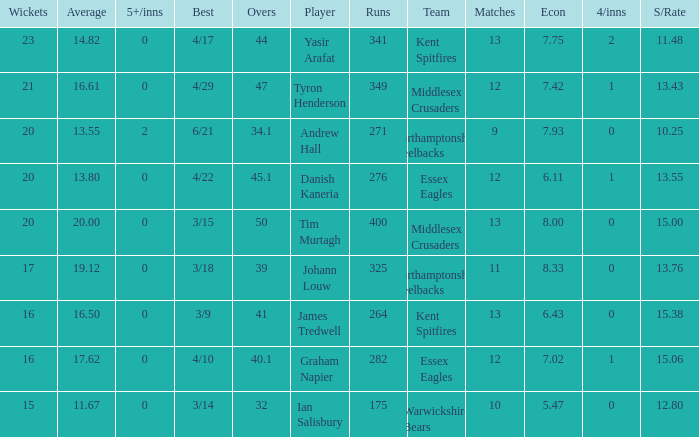Could you help me parse every detail presented in this table? {'header': ['Wickets', 'Average', '5+/inns', 'Best', 'Overs', 'Player', 'Runs', 'Team', 'Matches', 'Econ', '4/inns', 'S/Rate'], 'rows': [['23', '14.82', '0', '4/17', '44', 'Yasir Arafat', '341', 'Kent Spitfires', '13', '7.75', '2', '11.48'], ['21', '16.61', '0', '4/29', '47', 'Tyron Henderson', '349', 'Middlesex Crusaders', '12', '7.42', '1', '13.43'], ['20', '13.55', '2', '6/21', '34.1', 'Andrew Hall', '271', 'Northamptonshire Steelbacks', '9', '7.93', '0', '10.25'], ['20', '13.80', '0', '4/22', '45.1', 'Danish Kaneria', '276', 'Essex Eagles', '12', '6.11', '1', '13.55'], ['20', '20.00', '0', '3/15', '50', 'Tim Murtagh', '400', 'Middlesex Crusaders', '13', '8.00', '0', '15.00'], ['17', '19.12', '0', '3/18', '39', 'Johann Louw', '325', 'Northamptonshire Steelbacks', '11', '8.33', '0', '13.76'], ['16', '16.50', '0', '3/9', '41', 'James Tredwell', '264', 'Kent Spitfires', '13', '6.43', '0', '15.38'], ['16', '17.62', '0', '4/10', '40.1', 'Graham Napier', '282', 'Essex Eagles', '12', '7.02', '1', '15.06'], ['15', '11.67', '0', '3/14', '32', 'Ian Salisbury', '175', 'Warwickshire Bears', '10', '5.47', '0', '12.80']]} Name the most 4/inns 2.0. 